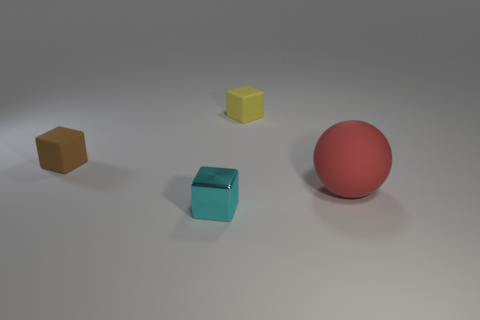There is a object right of the yellow rubber block; does it have the same size as the small brown rubber cube?
Give a very brief answer. No. How many brown rubber objects are the same shape as the tiny cyan metal object?
Provide a short and direct response. 1. What is the size of the yellow cube that is made of the same material as the big red ball?
Your answer should be very brief. Small. Are there an equal number of big red things in front of the large red matte object and large red matte spheres?
Keep it short and to the point. No. Is the large rubber thing the same color as the metallic cube?
Ensure brevity in your answer.  No. There is a big matte thing in front of the brown cube; is it the same shape as the small object that is to the left of the tiny metallic cube?
Keep it short and to the point. No. There is a small brown thing that is the same shape as the tiny yellow thing; what is its material?
Keep it short and to the point. Rubber. There is a matte object that is on the left side of the red matte object and right of the tiny brown thing; what color is it?
Offer a terse response. Yellow. There is a matte block in front of the small matte thing on the right side of the brown matte thing; are there any objects that are left of it?
Provide a short and direct response. No. How many objects are tiny yellow objects or large brown rubber cylinders?
Offer a very short reply. 1. 